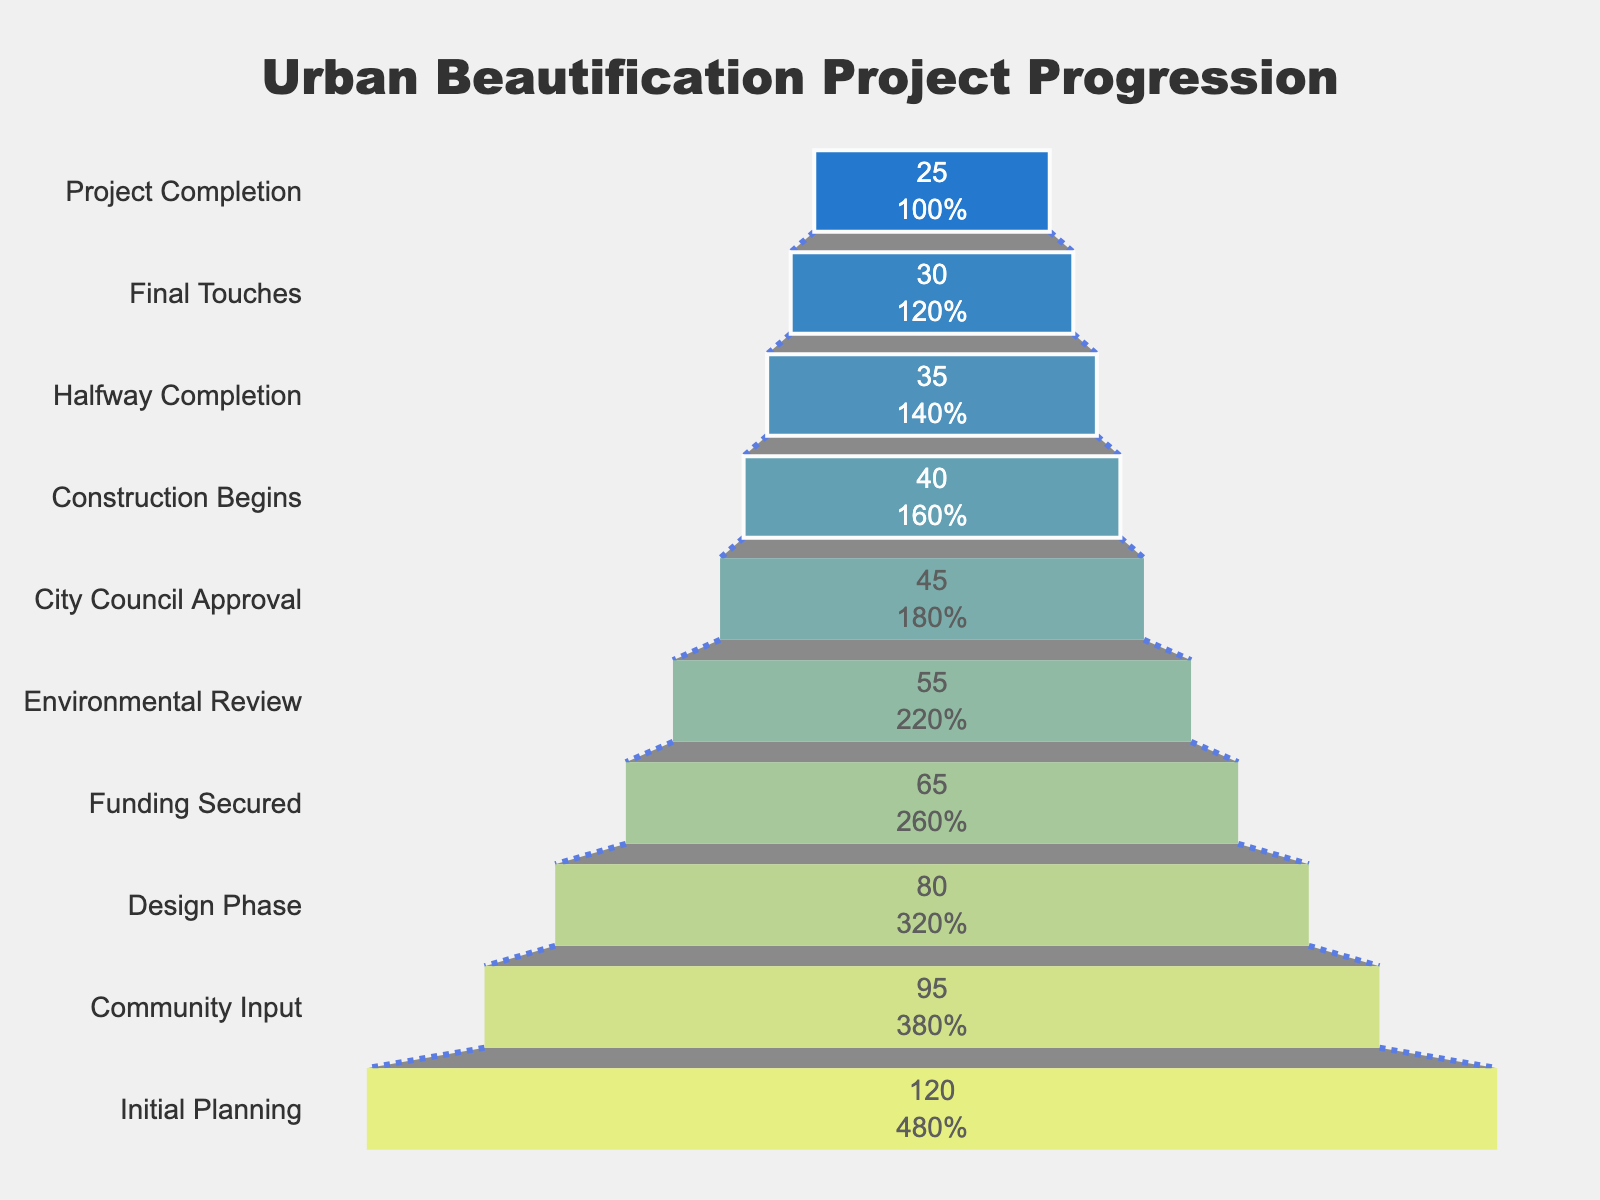What is the title of the funnel chart? The title of the chart is positioned at the top center and is styled in a large, bold font. By reading the title, "Urban Beautification Project Progression," we can identify it clearly.
Answer: Urban Beautification Project Progression What is the first stage of the urban beautification projects? The first stage is found at the top of the chart, where the group is labeled "Initial Planning," which indicates the starting point of the projects.
Answer: Initial Planning How many projects were completed by the end? The final stage, "Project Completion," shows the number of projects that reached the final stage, which is indicated as 25 projects.
Answer: 25 What is the value difference between the 'Design Phase' and 'Construction Begins' steps? By locating these two stages on the funnel chart and noting their respective values, we see 'Design Phase' has 80 projects and 'Construction Begins' has 40 projects. The difference is calculated as 80 - 40.
Answer: 40 What percentage of projects reached City Council Approval from Initial Planning? The initial number of projects is 120, and the number reaching City Council Approval is 45. The percentage is (45/120) * 100.
Answer: 37.5% How many stages are there in the urban beautification process shown in the chart? Counting the distinct labeled stages in the funnel chart from the top to the bottom, there are 10 total stages.
Answer: 10 Which stage experienced the highest drop in project numbers from the previous stage? By examining the differences between each consecutive stage's values, the largest drop occurs between the 'Design Phase' (80 projects) and 'Funding Secured' (65 projects), which has a drop of 15 projects.
Answer: Design Phase to Funding Secured What is the sum of projects in the 'Final Touches' and 'Community Input' stages? The number of projects in 'Final Touches' is 30 and in 'Community Input' is 95. Adding these together gives 30 + 95.
Answer: 125 How many projects dropped out during the Environmental Review phase? By comparing the values of the 'Environmental Review' stage (55 projects) and the preceding 'Funding Secured' stage (65 projects), the difference is 65 - 55.
Answer: 10 